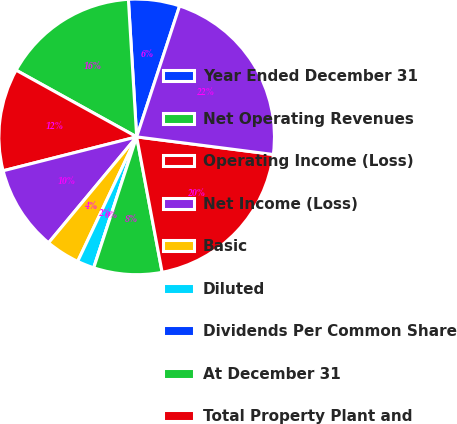Convert chart. <chart><loc_0><loc_0><loc_500><loc_500><pie_chart><fcel>Year Ended December 31<fcel>Net Operating Revenues<fcel>Operating Income (Loss)<fcel>Net Income (Loss)<fcel>Basic<fcel>Diluted<fcel>Dividends Per Common Share<fcel>At December 31<fcel>Total Property Plant and<fcel>Total Assets (1)<nl><fcel>6.0%<fcel>16.0%<fcel>12.0%<fcel>10.0%<fcel>4.0%<fcel>2.0%<fcel>0.0%<fcel>8.0%<fcel>20.0%<fcel>22.0%<nl></chart> 